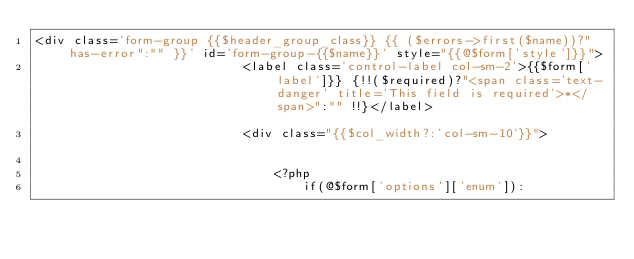<code> <loc_0><loc_0><loc_500><loc_500><_PHP_><div class='form-group {{$header_group_class}} {{ ($errors->first($name))?"has-error":"" }}' id='form-group-{{$name}}' style="{{@$form['style']}}">
							<label class='control-label col-sm-2'>{{$form['label']}} {!!($required)?"<span class='text-danger' title='This field is required'>*</span>":"" !!}</label>							
							<div class="{{$col_width?:'col-sm-10'}}">					

								<?php 
									if(@$form['options']['enum']):</code> 